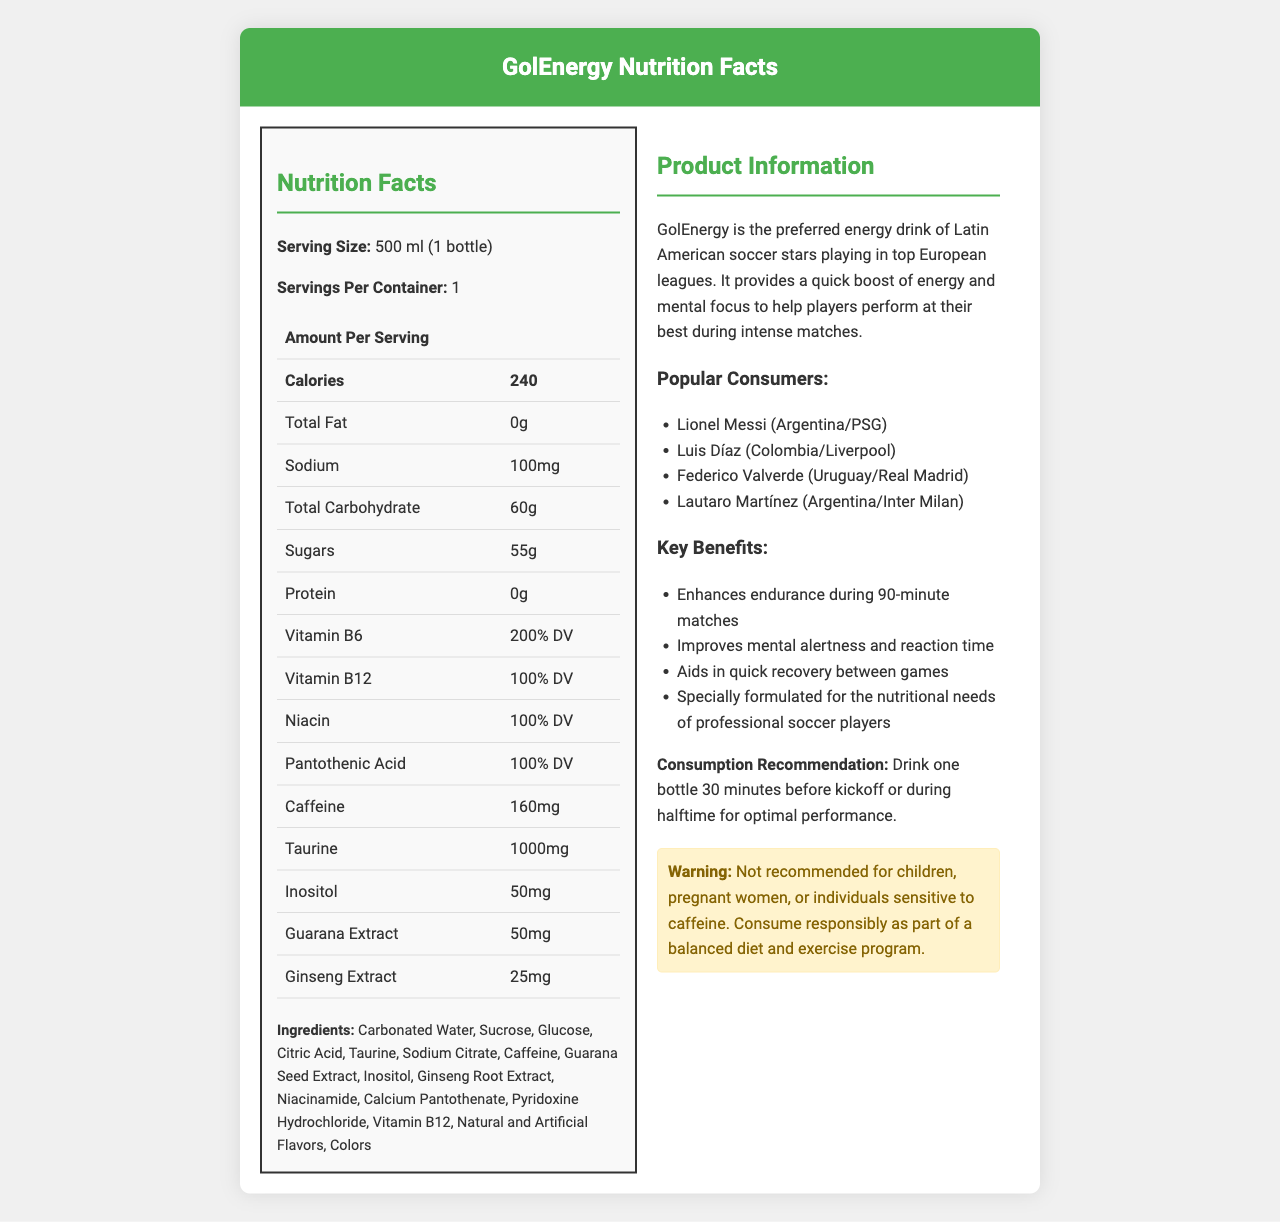who are some of the Latin American soccer players who consume GolEnergy? The document lists these players under the "Popular Consumers" section.
Answer: Lionel Messi, Luis Díaz, Federico Valverde, Lautaro Martínez what is the serving size for GolEnergy? The serving size is mentioned under the "Nutrition Facts" section.
Answer: 500 ml (1 bottle) how many calories are in one serving of GolEnergy? The calorie count is listed in the "Amount Per Serving" section of the document.
Answer: 240 what is the caffeine content in GolEnergy? The amount of caffeine is specified in the nutrition table under "Caffeine."
Answer: 160mg what are the key benefits of drinking GolEnergy during a soccer match? These benefits are listed in the "Key Benefits" section.
Answer: Enhances endurance, improves mental alertness and reaction time, aids in quick recovery, specially formulated for professional soccer players how much sugar does GolEnergy contain per serving? The sugar content is listed in the "Amount Per Serving" section of the document.
Answer: 55g which ingredient in GolEnergy might help with mental alertness? A. Taurine B. Guarana Extract C. Vitamin B6 D. Inositol Guarana Extract is known for its stimulant properties that help with mental alertness.
Answer: B. Guarana Extract what percentage of the daily value of Vitamin B6 is in one serving of GolEnergy? A. 50% B. 100% C. 200% D. 150% The document lists Vitamin B6 as having 200% of the daily value.
Answer: C. 200% can children consume GolEnergy? The warning section specifically states that it is not recommended for children.
Answer: No what is the main idea of the document? The document is structured to give a comprehensive overview of the energy drink, focusing on how it benefits professional soccer players.
Answer: GolEnergy provides a detailed overview of a popular energy drink consumed by Latin American soccer players in European clubs, highlighting its nutritional facts, ingredients, key benefits, and consumption recommendations. what is the primary function of Pantothenic Acid in this energy drink? The document does not provide enough information to determine the specific role of Pantothenic Acid in GolEnergy.
Answer: Cannot be determined 